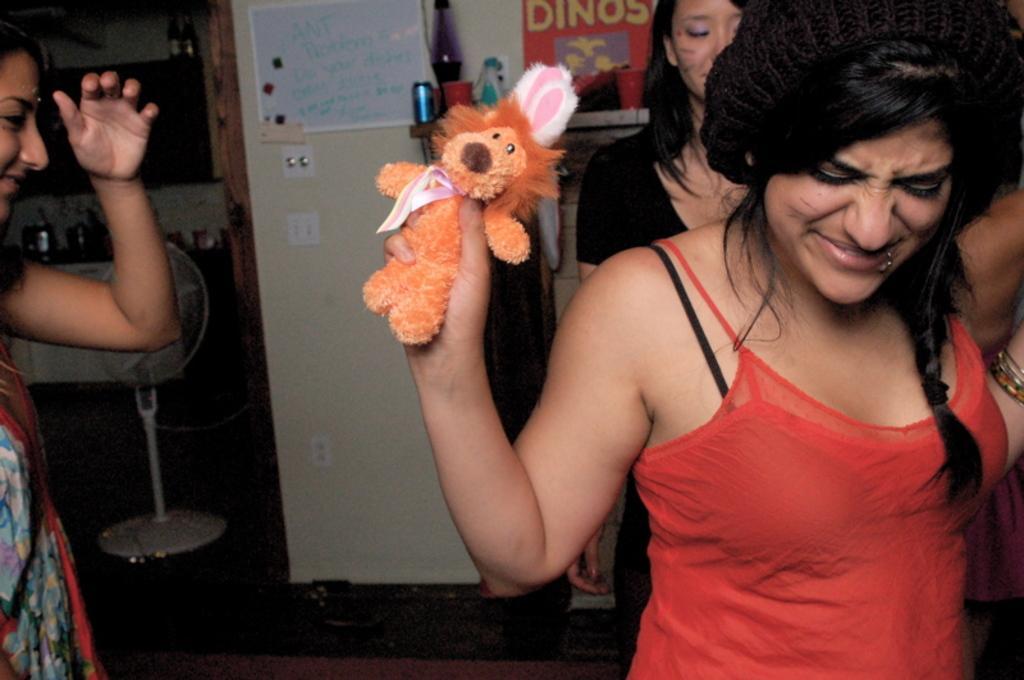In one or two sentences, can you explain what this image depicts? In this image, we can see people and one of them is holding a toy and wearing a cap. In the background, there are boards on the wall and we can see a table fan and some other objects. 